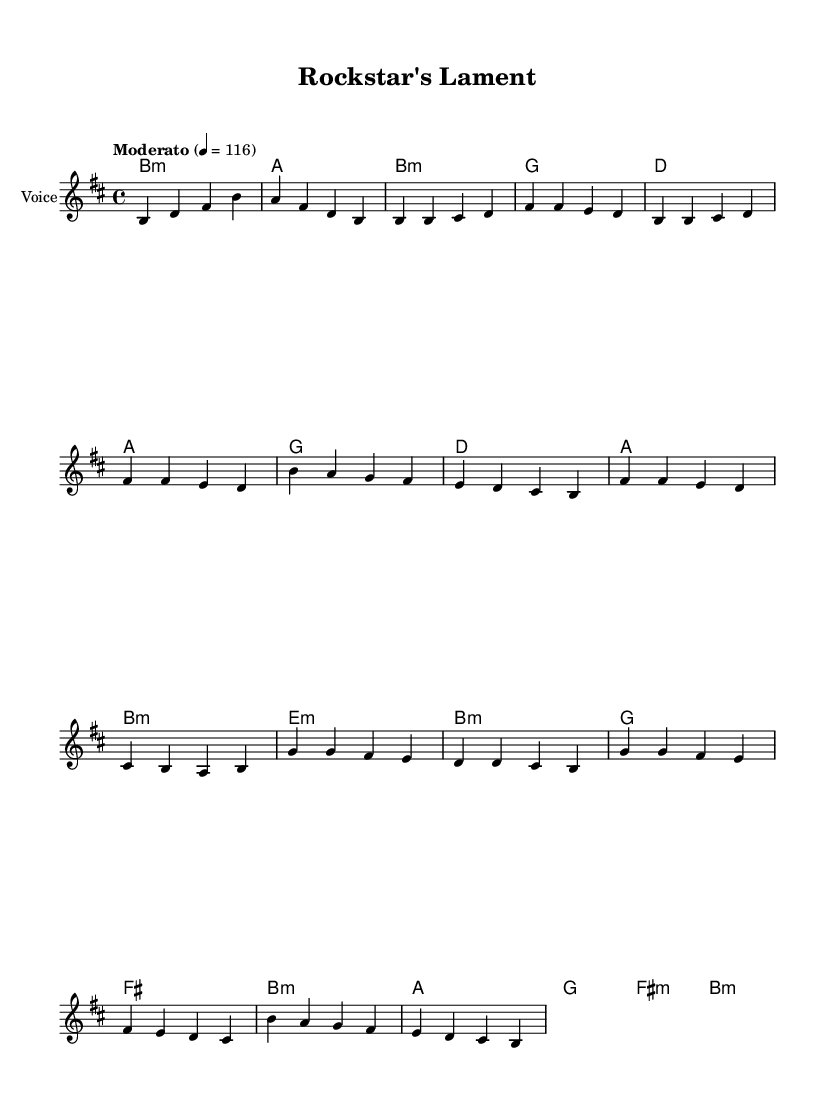What is the key signature of this music? The key signature is determined by the number of sharps or flats shown at the beginning of the staff. In this case, the key signature has two sharps, indicating B minor.
Answer: B minor What is the time signature of this music? The time signature is indicated by the numbers at the beginning of the staff. Here, it shows 4/4, meaning there are four beats per measure, and the quarter note gets one beat.
Answer: 4/4 What is the tempo marking of this piece? The tempo marking is indicated at the beginning of the music with the term "Moderato" and a speed of 116 beats per minute. This indicates a moderately paced piece.
Answer: Moderato How many sections are there in the song structure? To determine the number of sections, we analyze the music for distinct parts. The structure can be identified as Intro, Verse, Chorus, Bridge, and Outro, which totals five sections.
Answer: 5 What is the chord used in the bridge section? The bridge section starts with an E minor chord, as indicated in the chord symbols written above the staff. This shows that the chord is specifically notated at the beginning of the bridge.
Answer: E minor What is the highest note in the chorus? The highest note in the chorus can be identified by the pitches shown in the staff during that section. Here, the highest note is B, which is noted as B' (octave higher).
Answer: B Which section has the most rhythmic variation? By analyzing the sections visually, the Bridge section has differing note lengths and varied rhythms compared to more consistent patterns in the Chorus and Verse, indicating the most rhythmic variation is found here.
Answer: Bridge 